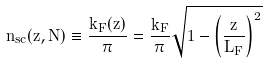Convert formula to latex. <formula><loc_0><loc_0><loc_500><loc_500>n _ { s c } ( z , N ) \equiv \frac { k _ { F } ( z ) } { \pi } = \frac { k _ { F } } { \pi } \sqrt { 1 - \left ( \frac { z } { L _ { F } } \right ) ^ { 2 } }</formula> 